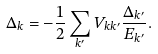<formula> <loc_0><loc_0><loc_500><loc_500>\Delta _ { k } = - \frac { 1 } { 2 } \sum _ { k ^ { \prime } } V _ { k k ^ { \prime } } \frac { \Delta _ { k ^ { \prime } } } { E _ { k ^ { \prime } } } .</formula> 